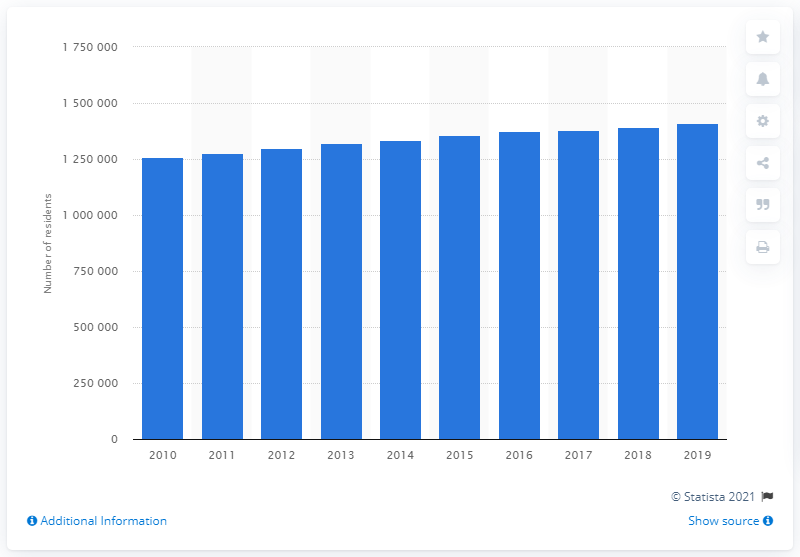Outline some significant characteristics in this image. In 2019, the Oklahoma City metropolitan area was home to 1,408,950 people. 